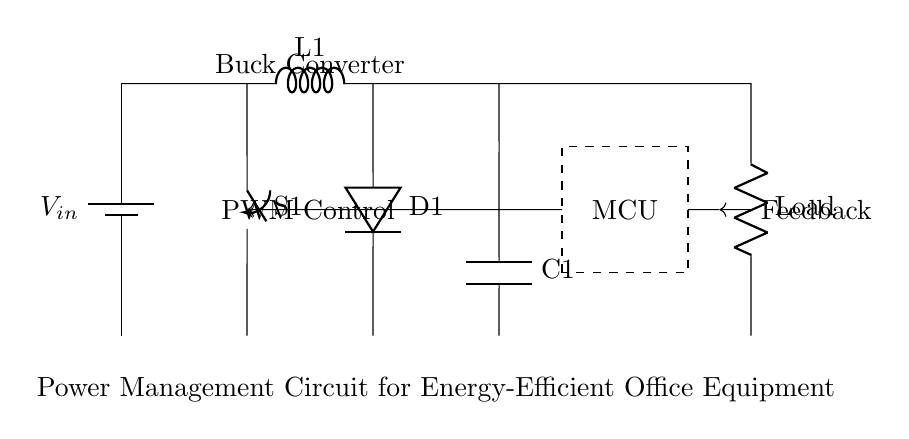What is the input voltage of this circuit? The input voltage is represented by V_{in}, which is connected to the power supply at the top of the circuit.
Answer: V_{in} What type of converter is used in this circuit? The circuit includes a buck converter, as indicated by the label near the components and its function of stepping down voltage.
Answer: Buck Converter What component is labeled C1? C1 is a capacitor, which is shown in the circuit to smooth out voltage fluctuations and store energy.
Answer: Capacitor What does S1 represent in this circuit? S1 is a switch, which is used to connect or disconnect the circuit path, allowing for control over the current flow.
Answer: Switch What is the purpose of the feedback connection? The feedback connection is used to monitor the output and provide input to the PWM control for regulating the output voltage.
Answer: Regulation How many main components are part of this circuit? The main components include one battery, one buck converter, a microcontroller, a load resistor, one switch, one diode, and one capacitor, totaling seven primary components.
Answer: Seven What role does the microcontroller play in this circuit? The microcontroller is responsible for controlling the PWM signal, which adjusts the output of the buck converter for optimal power management.
Answer: Control 